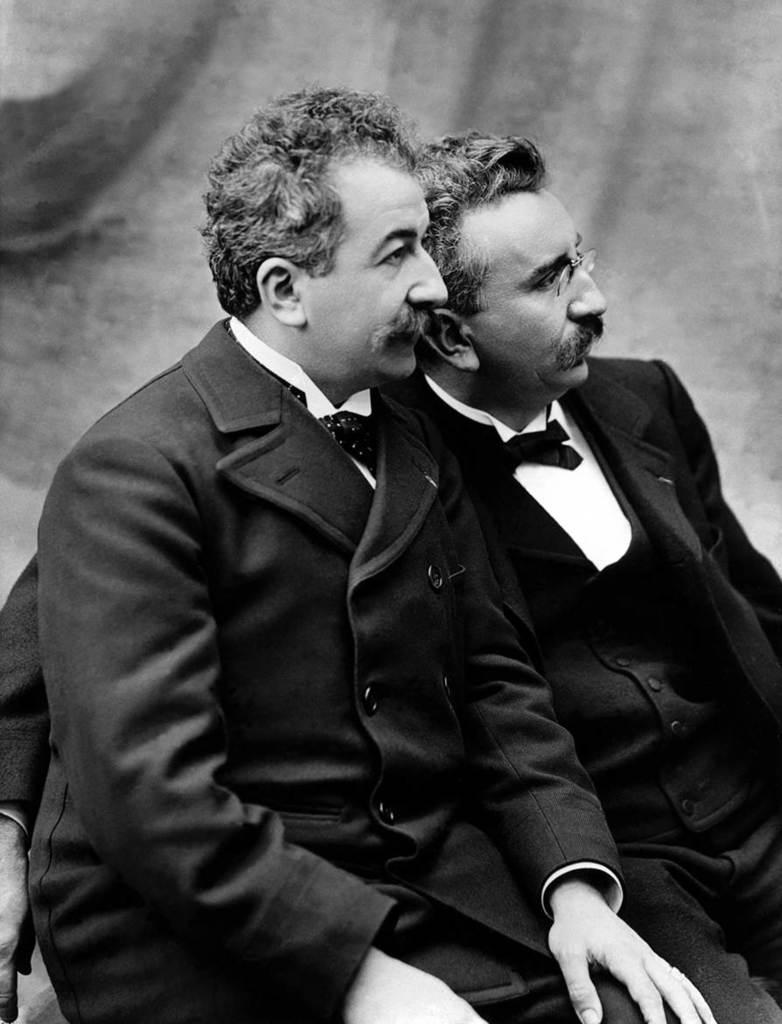What is the color scheme of the image? The image is black and white. How many people are in the image? There are two men sitting in the image. What is located behind the men? There is a wall behind the men. What type of tank can be seen in the image? There is no tank present in the image; it only features two men sitting and a wall behind them. 